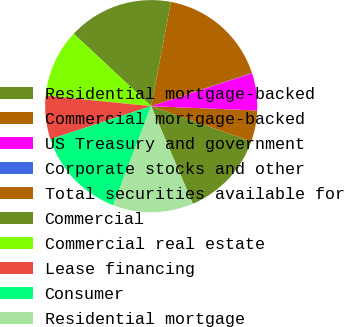<chart> <loc_0><loc_0><loc_500><loc_500><pie_chart><fcel>Residential mortgage-backed<fcel>Commercial mortgage-backed<fcel>US Treasury and government<fcel>Corporate stocks and other<fcel>Total securities available for<fcel>Commercial<fcel>Commercial real estate<fcel>Lease financing<fcel>Consumer<fcel>Residential mortgage<nl><fcel>13.19%<fcel>4.74%<fcel>5.68%<fcel>0.05%<fcel>16.95%<fcel>16.01%<fcel>10.38%<fcel>6.62%<fcel>14.13%<fcel>12.25%<nl></chart> 